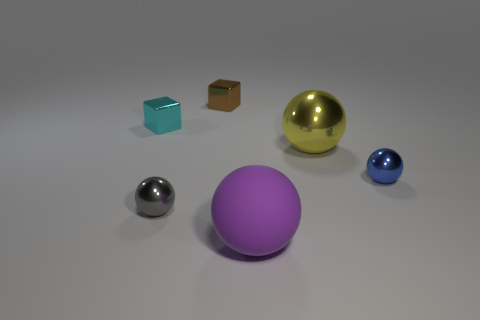Are the objects arranged in any particular order or pattern? The objects appear to be deliberately spaced across the surface, generating a sense of balance without a strict pattern. The varying sizes and colors of the objects create a visually appealing spread with the larger, purple, and golden spheres anchoring the composition. 